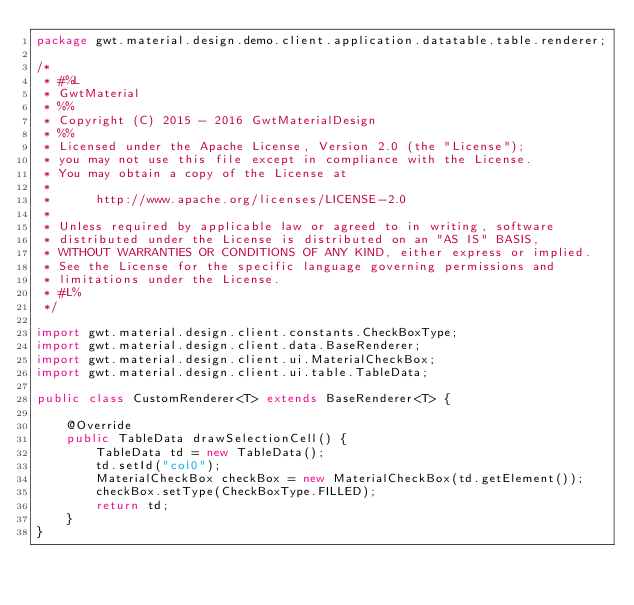<code> <loc_0><loc_0><loc_500><loc_500><_Java_>package gwt.material.design.demo.client.application.datatable.table.renderer;

/*
 * #%L
 * GwtMaterial
 * %%
 * Copyright (C) 2015 - 2016 GwtMaterialDesign
 * %%
 * Licensed under the Apache License, Version 2.0 (the "License");
 * you may not use this file except in compliance with the License.
 * You may obtain a copy of the License at
 * 
 *      http://www.apache.org/licenses/LICENSE-2.0
 * 
 * Unless required by applicable law or agreed to in writing, software
 * distributed under the License is distributed on an "AS IS" BASIS,
 * WITHOUT WARRANTIES OR CONDITIONS OF ANY KIND, either express or implied.
 * See the License for the specific language governing permissions and
 * limitations under the License.
 * #L%
 */

import gwt.material.design.client.constants.CheckBoxType;
import gwt.material.design.client.data.BaseRenderer;
import gwt.material.design.client.ui.MaterialCheckBox;
import gwt.material.design.client.ui.table.TableData;

public class CustomRenderer<T> extends BaseRenderer<T> {

    @Override
    public TableData drawSelectionCell() {
        TableData td = new TableData();
        td.setId("col0");
        MaterialCheckBox checkBox = new MaterialCheckBox(td.getElement());
        checkBox.setType(CheckBoxType.FILLED);
        return td;
    }
}
</code> 